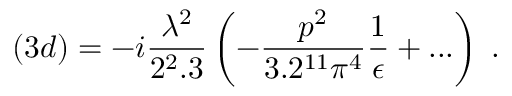<formula> <loc_0><loc_0><loc_500><loc_500>( 3 d ) = - i \frac { \lambda ^ { 2 } } { 2 ^ { 2 } . 3 } \left ( - \frac { p ^ { 2 } } { 3 . 2 ^ { 1 1 } \pi ^ { 4 } } \frac { 1 } { \epsilon } + \dots \right ) \, .</formula> 